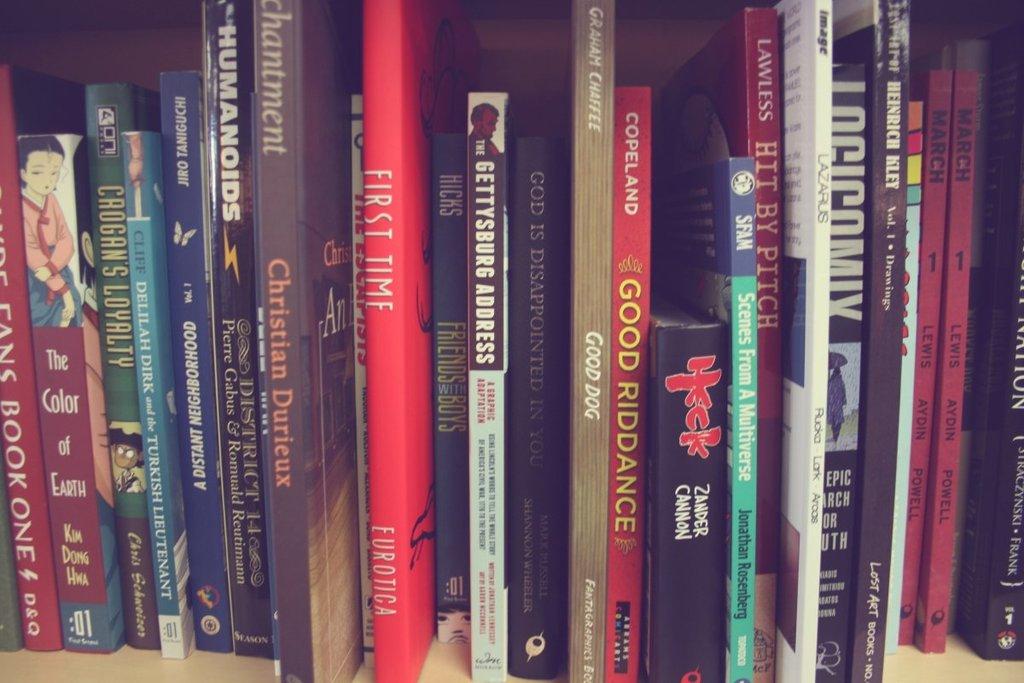What is the name of the bright red book in the middle?
Provide a succinct answer. First time. 